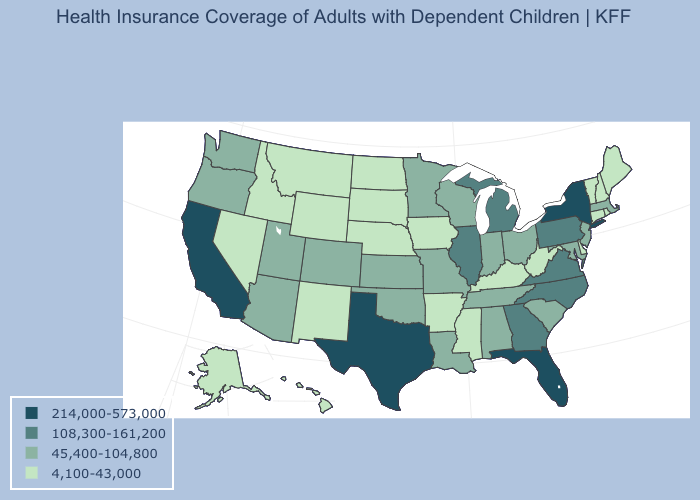What is the value of Utah?
Answer briefly. 45,400-104,800. What is the value of Missouri?
Answer briefly. 45,400-104,800. Name the states that have a value in the range 4,100-43,000?
Be succinct. Alaska, Arkansas, Connecticut, Delaware, Hawaii, Idaho, Iowa, Kentucky, Maine, Mississippi, Montana, Nebraska, Nevada, New Hampshire, New Mexico, North Dakota, Rhode Island, South Dakota, Vermont, West Virginia, Wyoming. Name the states that have a value in the range 45,400-104,800?
Write a very short answer. Alabama, Arizona, Colorado, Indiana, Kansas, Louisiana, Maryland, Massachusetts, Minnesota, Missouri, New Jersey, Ohio, Oklahoma, Oregon, South Carolina, Tennessee, Utah, Washington, Wisconsin. Does Montana have a lower value than South Carolina?
Give a very brief answer. Yes. Among the states that border Arkansas , does Mississippi have the lowest value?
Short answer required. Yes. What is the lowest value in the USA?
Keep it brief. 4,100-43,000. Among the states that border New York , does Massachusetts have the lowest value?
Give a very brief answer. No. Name the states that have a value in the range 4,100-43,000?
Write a very short answer. Alaska, Arkansas, Connecticut, Delaware, Hawaii, Idaho, Iowa, Kentucky, Maine, Mississippi, Montana, Nebraska, Nevada, New Hampshire, New Mexico, North Dakota, Rhode Island, South Dakota, Vermont, West Virginia, Wyoming. Which states have the highest value in the USA?
Answer briefly. California, Florida, New York, Texas. What is the value of Kentucky?
Quick response, please. 4,100-43,000. Does Vermont have the same value as Hawaii?
Be succinct. Yes. Does Washington have a higher value than Arkansas?
Keep it brief. Yes. Does Ohio have the lowest value in the USA?
Concise answer only. No. Does South Dakota have the highest value in the USA?
Quick response, please. No. 